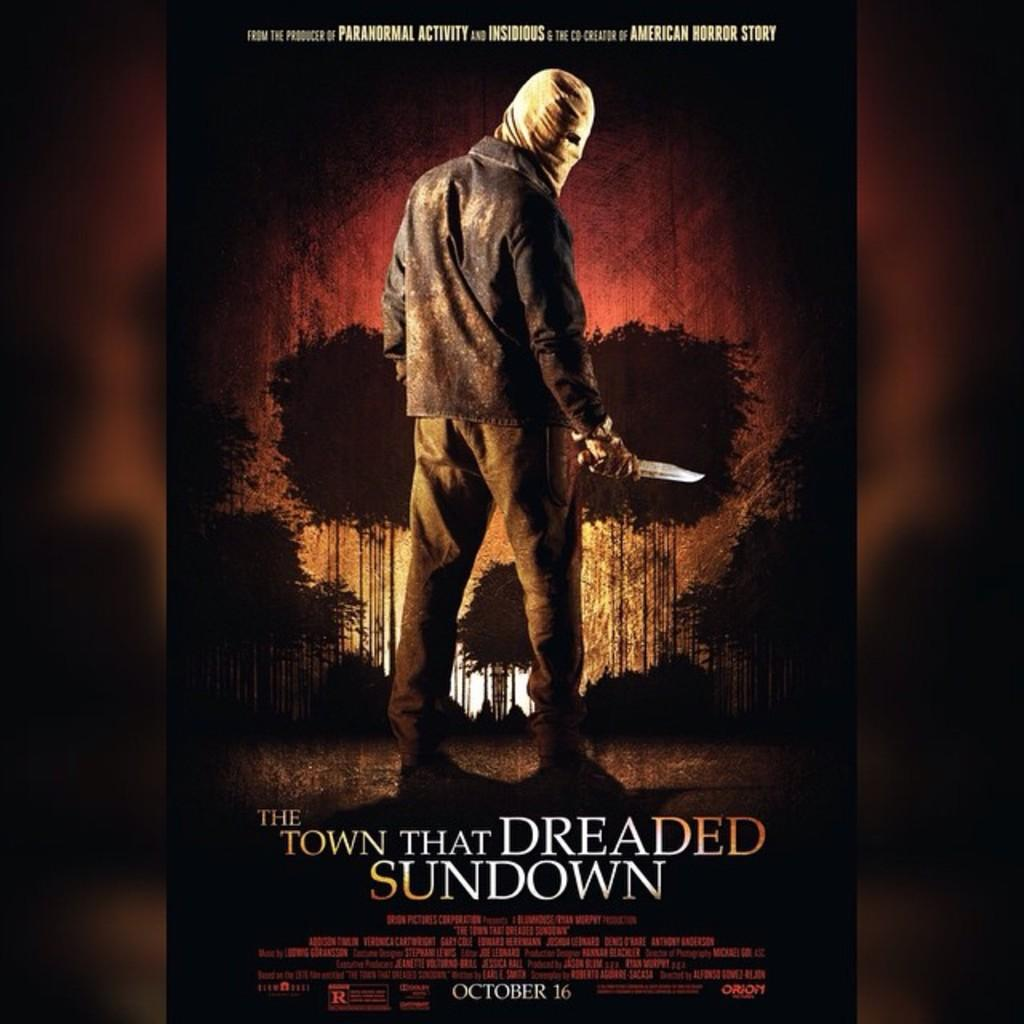<image>
Give a short and clear explanation of the subsequent image. A movie poster of The Town that Dreaded Sundown 